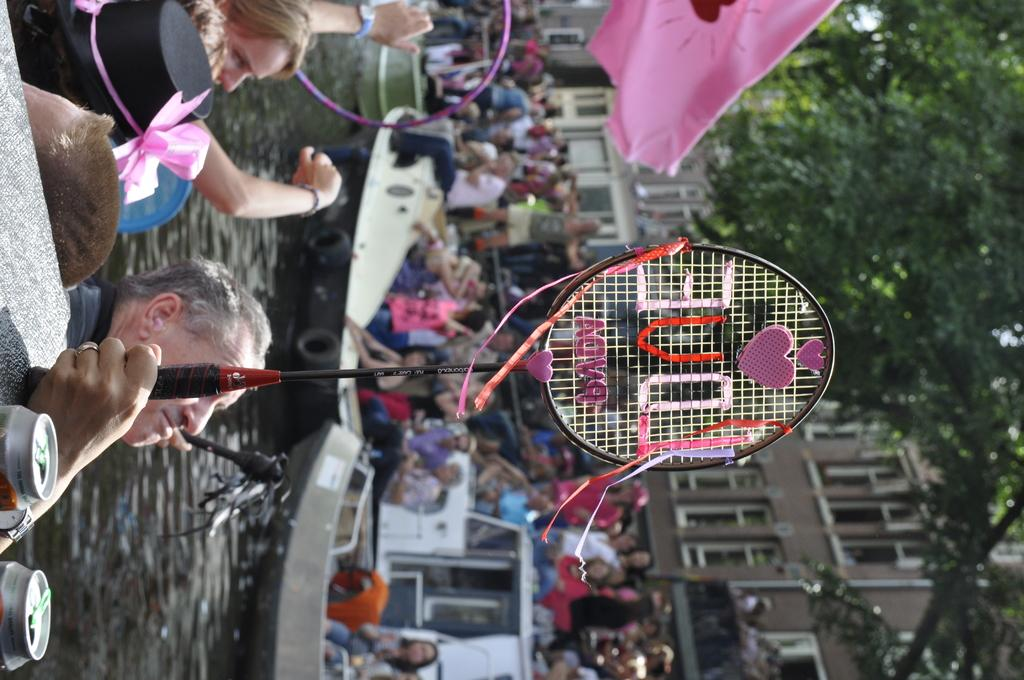What are the people in the image doing? The people in the image are on boats. What object is a person holding in the image? A person is holding a racket in the image. What type of bulb is being used to light up the scene in the image? There is no bulb present in the image; it is an outdoor scene with people on boats and a person holding a racket. 